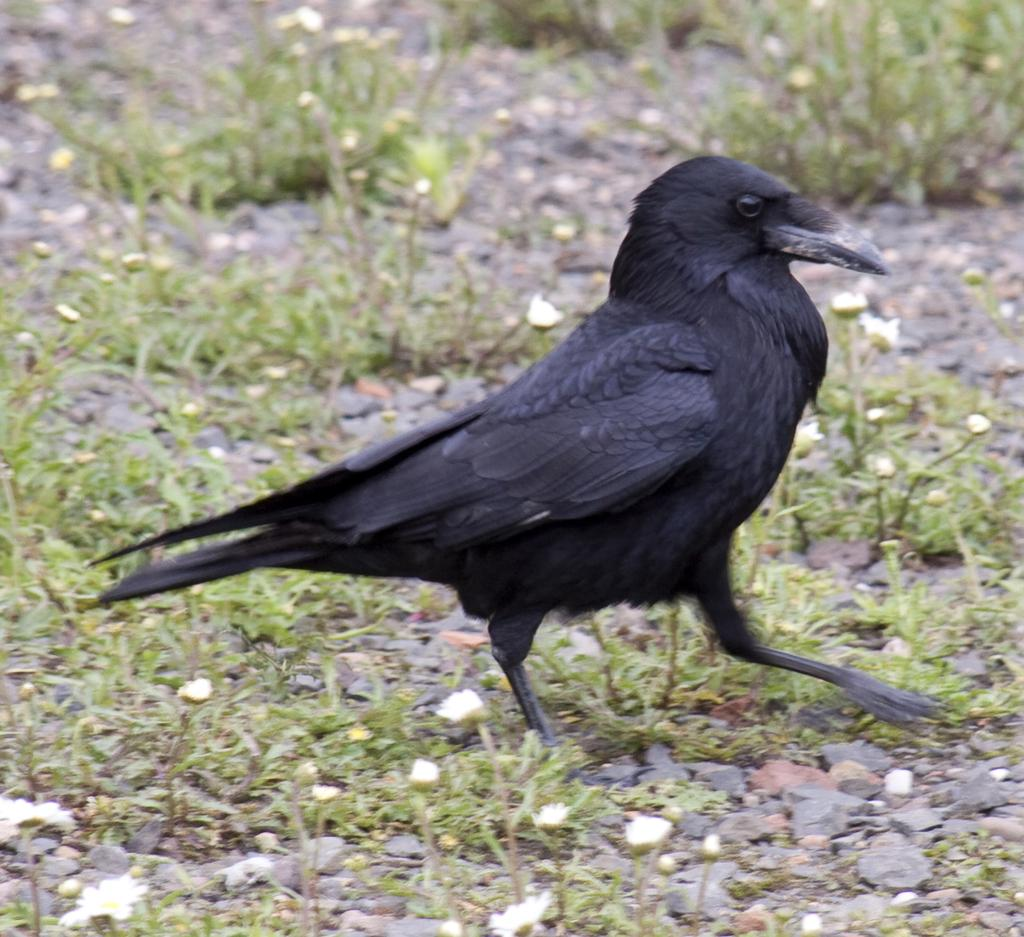What type of animal is present in the image? There is a bird in the image. What is the bird doing in the image? The bird is walking on the ground. What can be seen on the ground in the image? There are stones and grass on the ground. What type of hands does the bird have in the image? Birds do not have hands; they have wings and feet. In the image, the bird's feet are visible as it walks on the ground. 